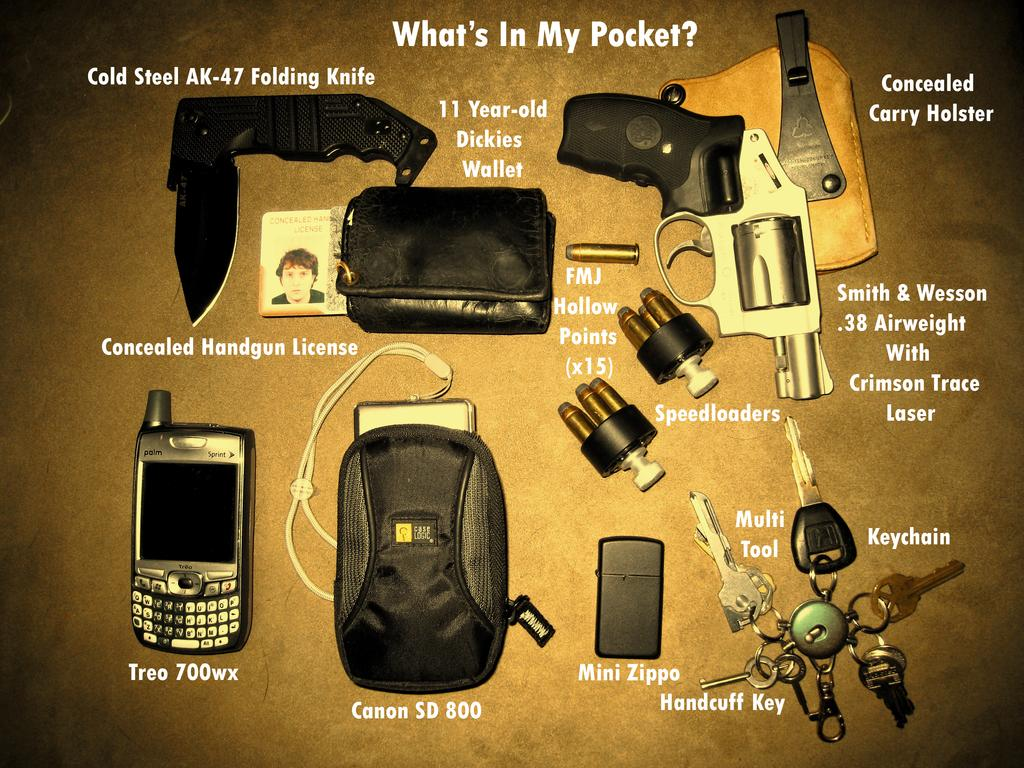Provide a one-sentence caption for the provided image. Multiple items displayed on a table includng a CanonSD 800, Mini Zippo, and Treo 700wx. 